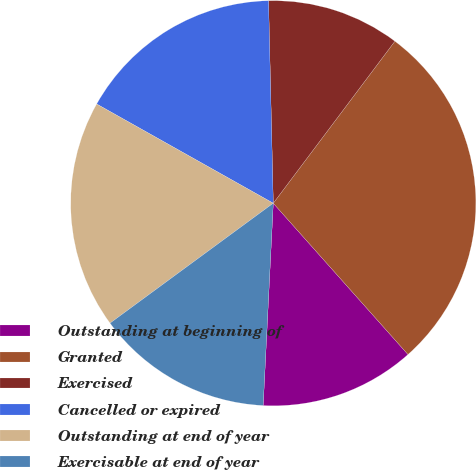Convert chart. <chart><loc_0><loc_0><loc_500><loc_500><pie_chart><fcel>Outstanding at beginning of<fcel>Granted<fcel>Exercised<fcel>Cancelled or expired<fcel>Outstanding at end of year<fcel>Exercisable at end of year<nl><fcel>12.37%<fcel>28.17%<fcel>10.62%<fcel>16.48%<fcel>18.23%<fcel>14.12%<nl></chart> 